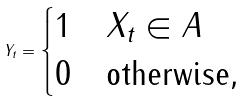<formula> <loc_0><loc_0><loc_500><loc_500>Y _ { t } = \begin{cases} 1 & X _ { t } \in A \\ 0 & \text {otherwise} , \end{cases}</formula> 